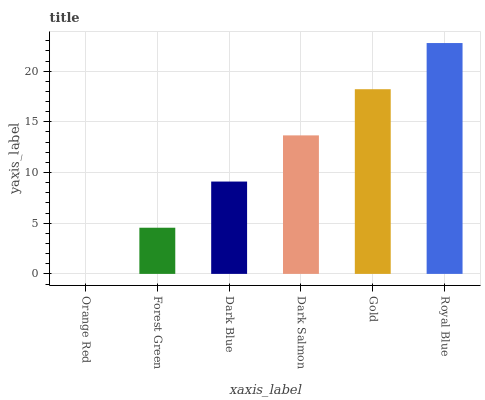Is Orange Red the minimum?
Answer yes or no. Yes. Is Royal Blue the maximum?
Answer yes or no. Yes. Is Forest Green the minimum?
Answer yes or no. No. Is Forest Green the maximum?
Answer yes or no. No. Is Forest Green greater than Orange Red?
Answer yes or no. Yes. Is Orange Red less than Forest Green?
Answer yes or no. Yes. Is Orange Red greater than Forest Green?
Answer yes or no. No. Is Forest Green less than Orange Red?
Answer yes or no. No. Is Dark Salmon the high median?
Answer yes or no. Yes. Is Dark Blue the low median?
Answer yes or no. Yes. Is Orange Red the high median?
Answer yes or no. No. Is Forest Green the low median?
Answer yes or no. No. 